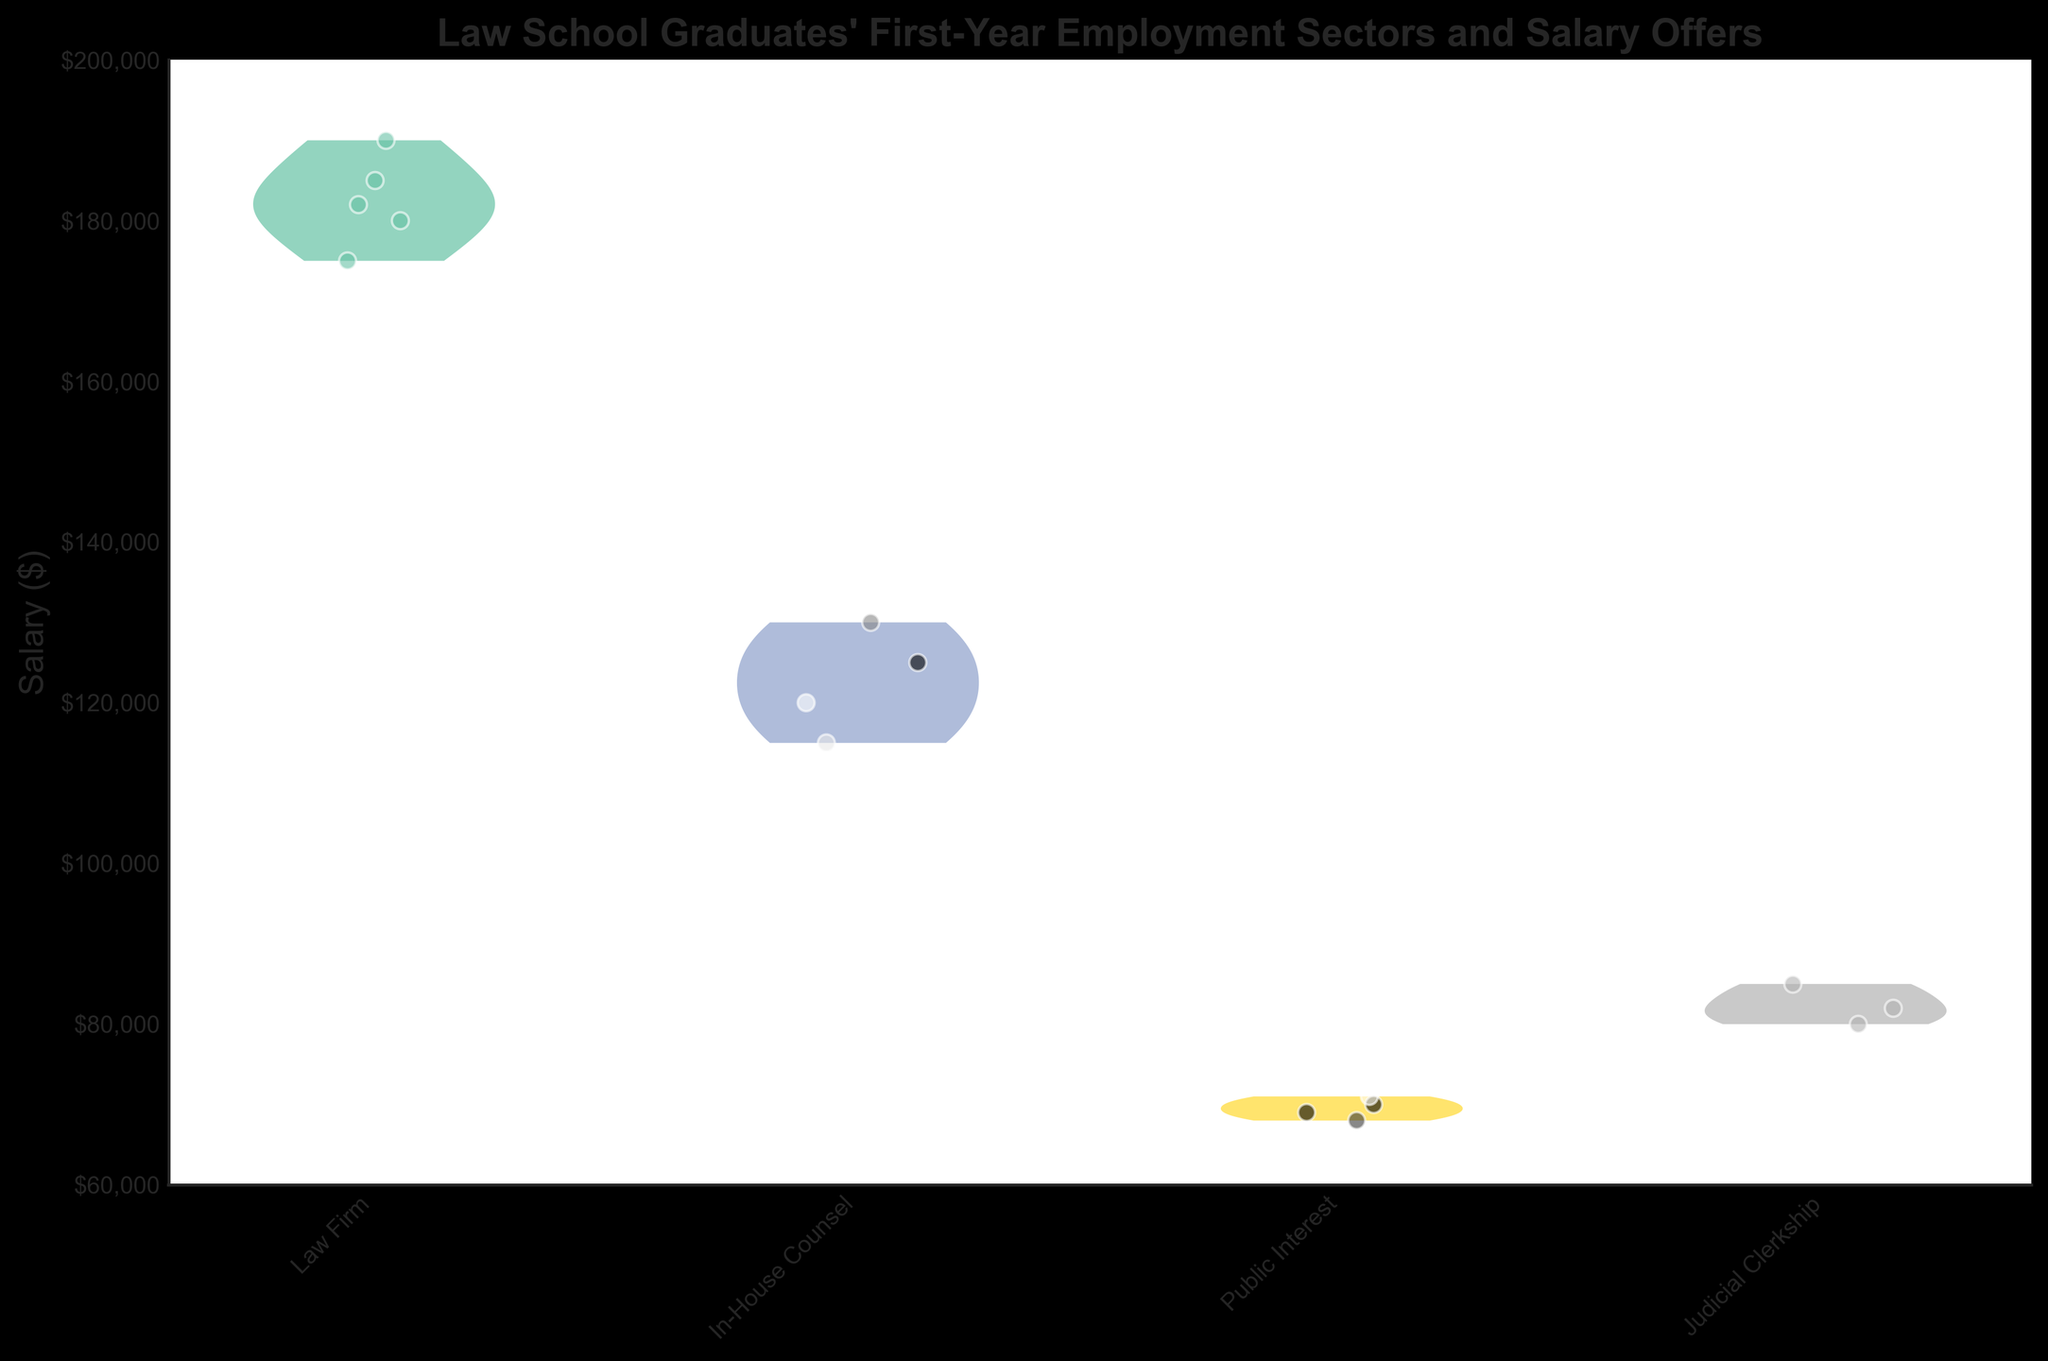What's the title of the chart? The title is usually displayed prominently at the top of the chart. In this case, the title is given as "Law School Graduates' First-Year Employment Sectors and Salary Offers".
Answer: Law School Graduates' First-Year Employment Sectors and Salary Offers What does each dot in the chart represent? Each dot represents an individual law school graduate's salary offer in a specific employment sector. The dots are jittered to reduce overlap and improve visibility.
Answer: An individual law school graduate's salary offer Which employment sector has the widest range of salaries? To find the sector with the widest range, observe the spread of the violins. The Law Firm sector has the widest spread, indicating significant variation in salary offers.
Answer: Law Firm What is the lowest salary observed, and in which sector is it? The lowest salary can be identified by looking at the bottom of the violins. The Public Interest sector has the lowest salary, around $68,000.
Answer: Public Interest, $68,000 Which employment sector has the highest concentration of salaries around a single value? The highest concentration can be seen in the density of the violin plot. The Law Firm sector appears to have a high concentration of salaries around $180,000-$190,000.
Answer: Law Firm How does the average salary of Judicial Clerkships compare to In-House Counsel? Observe both sectors' average positions within the violins. Judicial Clerkships have salaries averaging around $80,000-$85,000, while In-House Counsel salaries average around $115,000-$130,000.
Answer: Judicial Clerkships are lower What do the colors in the chart signify? The colors differentiate between the various employment sectors for clarity and visual separation.
Answer: Different employment sectors Are there any outliers visible in the data, and if so, in which sector(s)? Outliers in the context might appear significantly different from the rest of the data points. There don't seem to be any extreme outliers as most salaries fall within the expected ranges.
Answer: No significant outliers What is the approximate range of salaries for Public Interest employment? Examine the spread of the violins for Public Interest. The range appears to be from about $68,000 to $71,000.
Answer: $68,000 to $71,000 Which sector shows the smallest variation in salaries? By comparing the width and spread of all the violins, Public Interest is the sector with the smallest variation.
Answer: Public Interest 